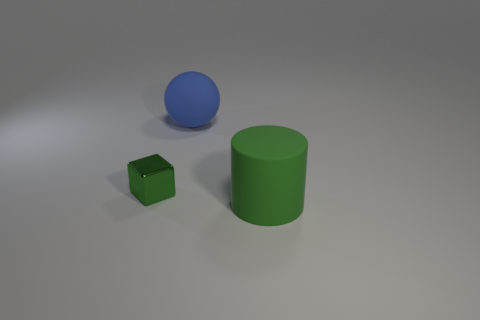There is a sphere that is the same material as the green cylinder; what is its size?
Offer a terse response. Large. How many green objects are tiny objects or large rubber cylinders?
Give a very brief answer. 2. What is the shape of the rubber thing that is the same color as the block?
Your answer should be very brief. Cylinder. Is there anything else that has the same material as the small object?
Make the answer very short. No. Does the large object behind the small object have the same shape as the object that is on the right side of the ball?
Provide a succinct answer. No. What number of red spheres are there?
Ensure brevity in your answer.  0. What shape is the large blue thing that is made of the same material as the large green cylinder?
Your response must be concise. Sphere. Are there any other things of the same color as the matte cylinder?
Provide a short and direct response. Yes. Does the shiny thing have the same color as the big matte thing in front of the big matte ball?
Offer a terse response. Yes. Is the number of metallic things that are to the right of the block less than the number of tiny green shiny blocks?
Give a very brief answer. Yes. 